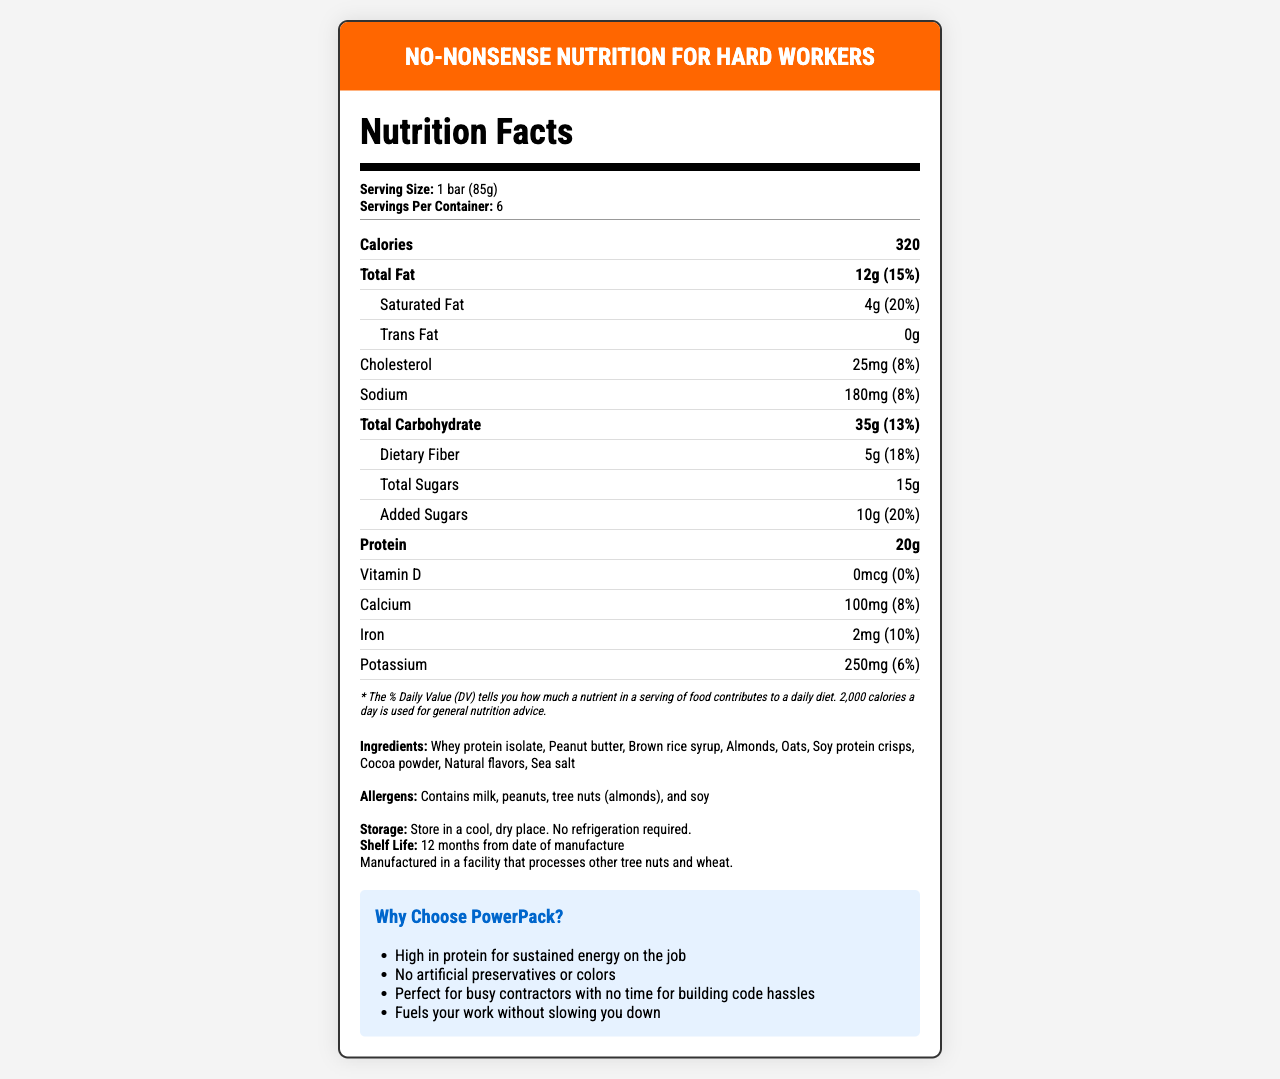what is the serving size of the PowerPack Construction Protein Bar? This information is located in the "Serving Size" section of the document.
Answer: 1 bar (85g) how many calories are there in one serving? The "Calories" section of the document indicates that one serving contains 320 calories.
Answer: 320 what percentage of the daily value of protein does one serving provide? The "Protein" section shows the daily value percentage as 40%.
Answer: 40% which ingredient is listed first in the ingredients section? The "Ingredients" section lists whey protein isolate as the first ingredient.
Answer: Whey protein isolate for how long can the PowerPack Construction Protein Bar be stored? The "Shelf Life" section contains this information.
Answer: 12 months from date of manufacture what is the total amount of fat in one serving? A. 12g B. 15g C. 20g D. 25g The "Total Fat" section lists the total fat content as 12g.
Answer: A. 12g how much sodium does one serving contain? A. 80mg B. 120mg C. 150mg D. 180mg The "Sodium" section indicates that one serving contains 180mg of sodium.
Answer: D. 180mg are there any artificial preservatives or colors in the PowerPack Construction Protein Bar? One of the marketing claims specifically states, "No artificial preservatives or colors."
Answer: No do the bars need to be refrigerated? The "Storage Instructions" section notes that no refrigeration is required.
Answer: No what allergens are contained in this product? The "Allergens" section provides this information.
Answer: Milk, peanuts, tree nuts (almonds), and soy what is the product name and its main nutritional benefit? The product name is "PowerPack Construction Protein Bar." The main nutritional benefit, as indicated in the marketing claims, is being high in protein for sustained energy.
Answer: PowerPack Construction Protein Bar, high in protein for sustained energy who is the manufacturer of the PowerPack Construction Protein Bar? The manufacturer is not mentioned directly in the document.
Answer: Cannot be determined summarize the purpose of the PowerPack Construction Protein Bar The document provides a detailed breakdown of nutritional facts, ingredient lists, allergen information, storage instructions, shelf life, and marketing claims, emphasizing its suitability for busy contractors and its high protein content for sustained energy.
Answer: It is a high-protein, shelf-stable food designed for hard-working contractors who need a convenient and nutritious energy source without refrigeration. how much potassium is in a serving? This is noted in the "Potassium" section under nutrient information.
Answer: 250mg what is the main target audience for this product according to the marketing claims? The marketing claims specifically mention "Perfect for busy contractors."
Answer: Busy contractors is the amount of saturated fat higher than the amount of unsaturated fat? The document does not provide information on the amount of unsaturated fat.
Answer: Cannot be determined which statement best describes the dietary fiber content? A. Low in dietary fiber B. Moderate dietary fiber C. High in dietary fiber D. No dietary fiber The document shows that one serving contains 5g of dietary fiber, which is 18% of the daily value, indicating it is high in dietary fiber.
Answer: C. High in dietary fiber 